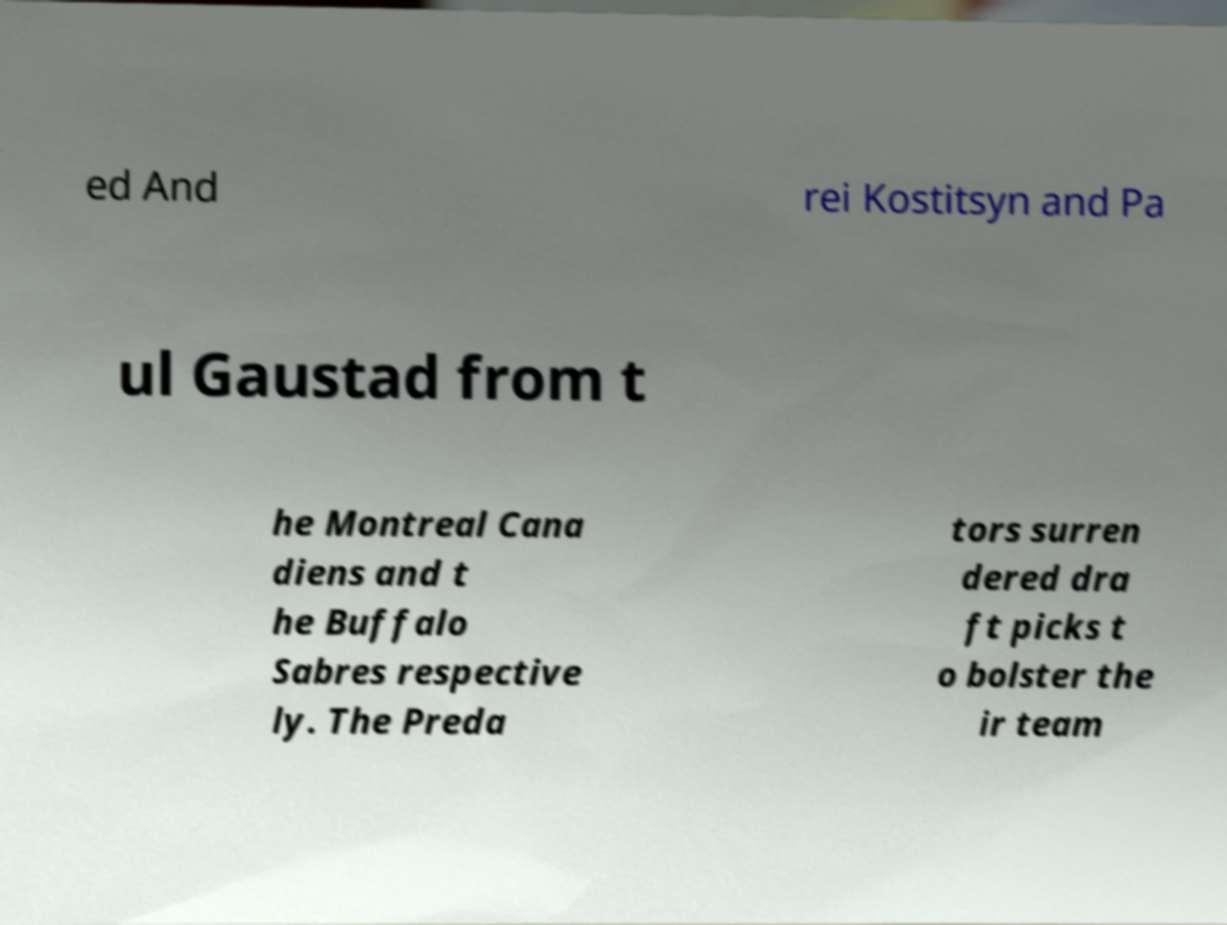I need the written content from this picture converted into text. Can you do that? ed And rei Kostitsyn and Pa ul Gaustad from t he Montreal Cana diens and t he Buffalo Sabres respective ly. The Preda tors surren dered dra ft picks t o bolster the ir team 